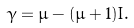<formula> <loc_0><loc_0><loc_500><loc_500>\gamma = \mu - ( \mu + 1 ) I .</formula> 